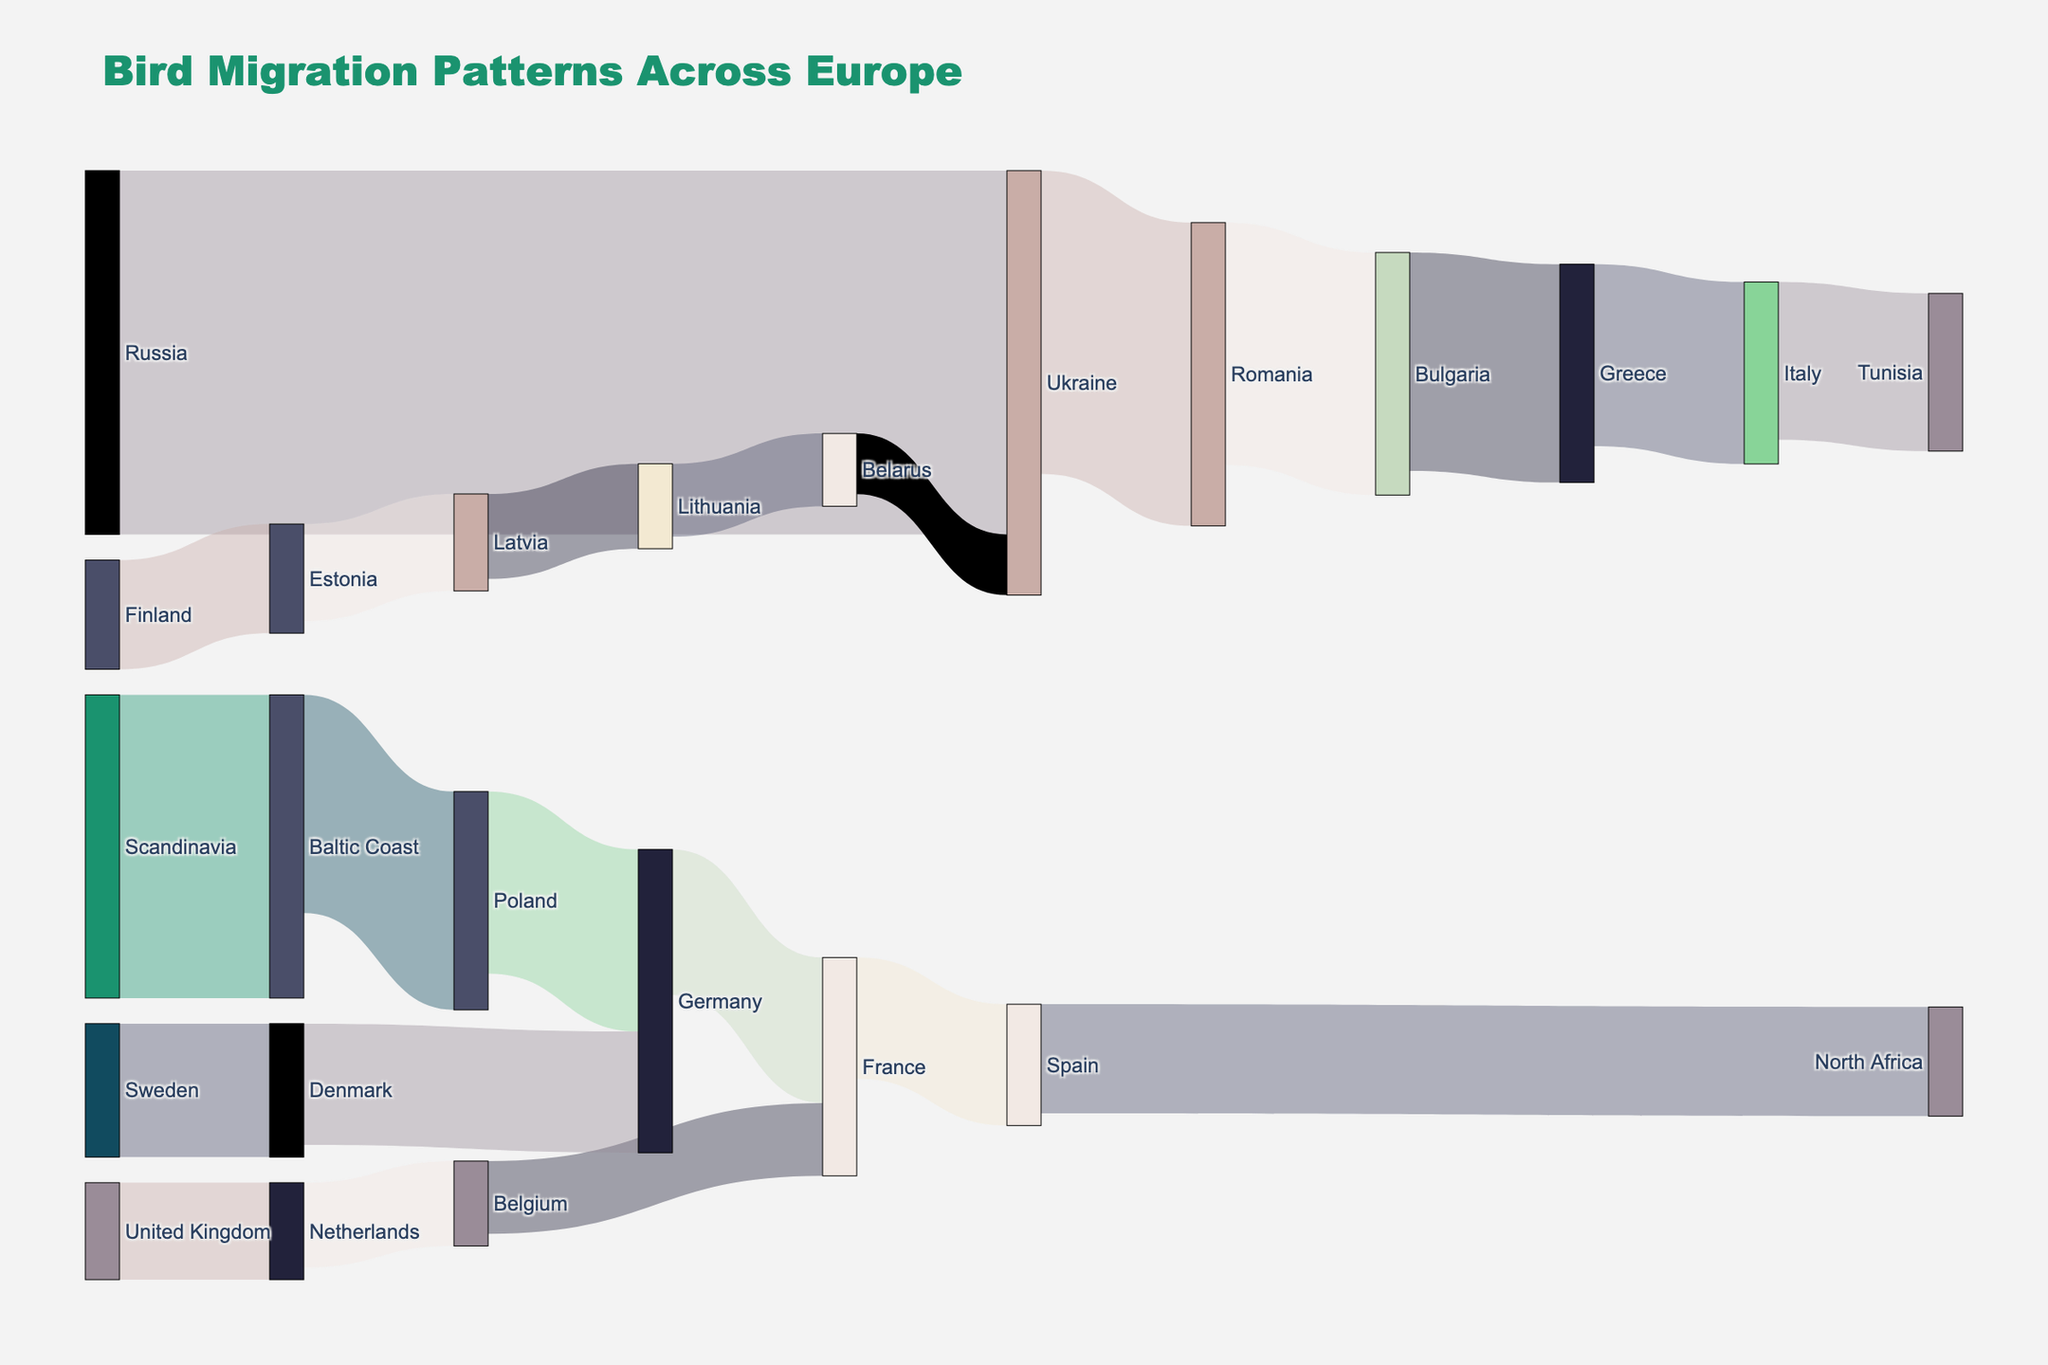What's the title of the figure? The title is located at the top of the figure and usually summarizes the content of the visualization. Here, the title "Bird Migration Patterns Across Europe" is clearly displayed.
Answer: Bird Migration Patterns Across Europe What is the thickest route shown in the Sankey diagram? The thickness of the links in a Sankey diagram represents the volume or value of the flow between nodes. The thickest route has the highest value associated with it, which is the flow from "Russia to Ukraine" with 300,000.
Answer: Russia to Ukraine Which country receives new birds from the most sources? By examining the target nodes in the Sankey diagram, identify which country appears most frequently as a target. Germany receives birds from both Poland and Denmark.
Answer: Germany How many birds migrate from Spain to North Africa? Look at the link connecting Spain to North Africa and note its value. The number of birds is 90,000.
Answer: 90,000 What is the total number of birds migrating through Poland? Sum up the birds entering and leaving Poland. 250,000 reach the Baltic Coast, and 150,000 leave for Germany, giving a total of 250,000.
Answer: 250,000 Which countries serve as the final destination for the migratory routes? Identify the countries at the end of the paths without further outbound connections. The final destinations are North Africa, Tunisia, and North Africa.
Answer: North Africa, Tunisia Between Germany and France, which country serves as a midpoint before reaching Spain? Trace the route from Germany to Spain through the intermediary country. The Sankey diagram shows that France serves as the midpoint.
Answer: France What is the second largest migratory flow in terms of bird numbers? Find the link with the second highest value. After Russia to Ukraine (300,000), the next highest value is from Scandinavia to Baltic Coast (250,000).
Answer: Scandinavia to Baltic Coast How many birds migrate from the United Kingdom via the Netherlands and Belgium before reaching France? Sum up the flows at each step: 80,000 from the UK to the Netherlands, 70,000 to Belgium, and 60,000 to France. The cumulative total of birds moving through these paths is 60,000.
Answer: 60,000 What color represents the node 'France' in the Sankey diagram? The nodes are color-coded, and you can match the colors to their labels. The node 'France' is represented by beige.
Answer: Beige 